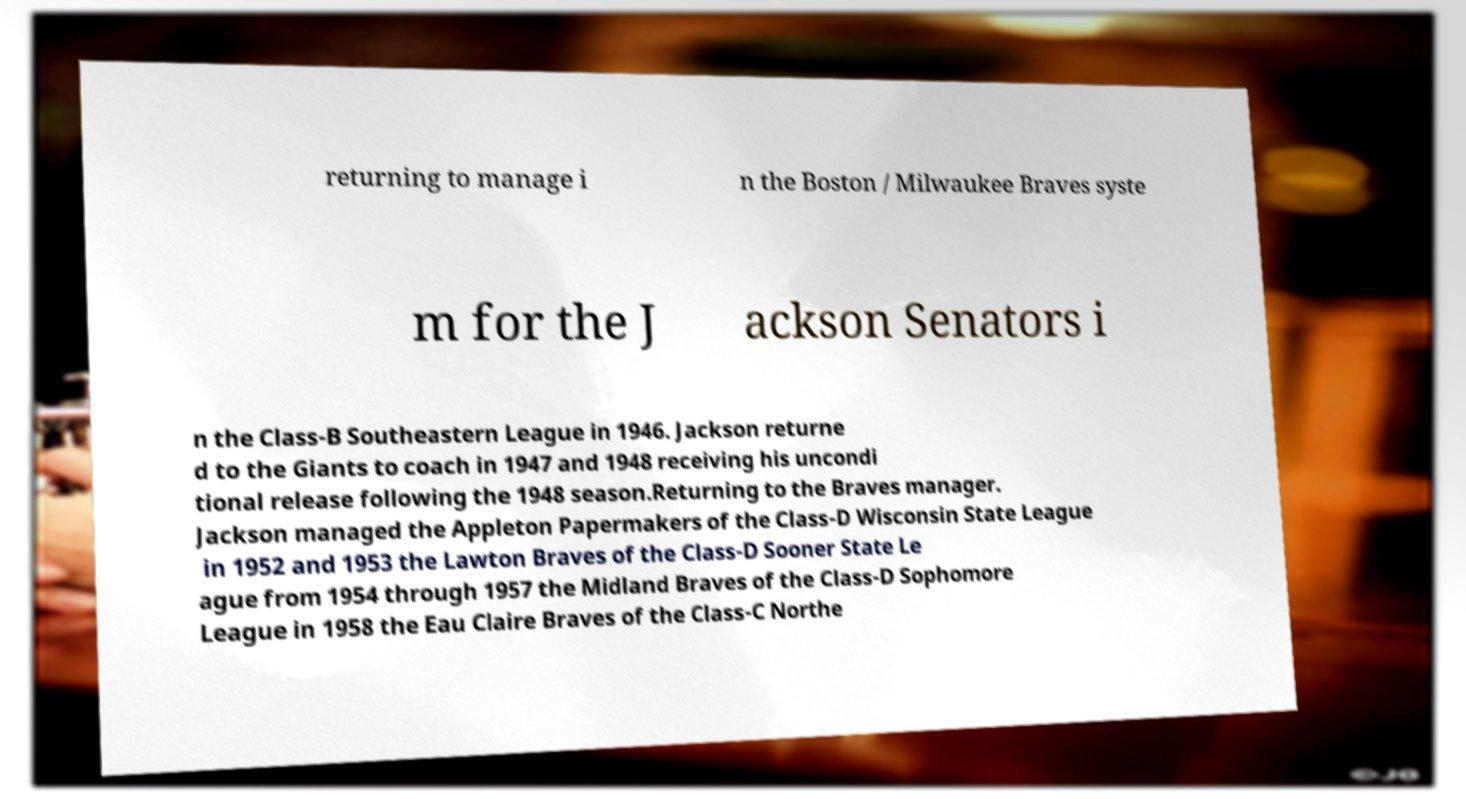Could you extract and type out the text from this image? returning to manage i n the Boston / Milwaukee Braves syste m for the J ackson Senators i n the Class-B Southeastern League in 1946. Jackson returne d to the Giants to coach in 1947 and 1948 receiving his uncondi tional release following the 1948 season.Returning to the Braves manager. Jackson managed the Appleton Papermakers of the Class-D Wisconsin State League in 1952 and 1953 the Lawton Braves of the Class-D Sooner State Le ague from 1954 through 1957 the Midland Braves of the Class-D Sophomore League in 1958 the Eau Claire Braves of the Class-C Northe 